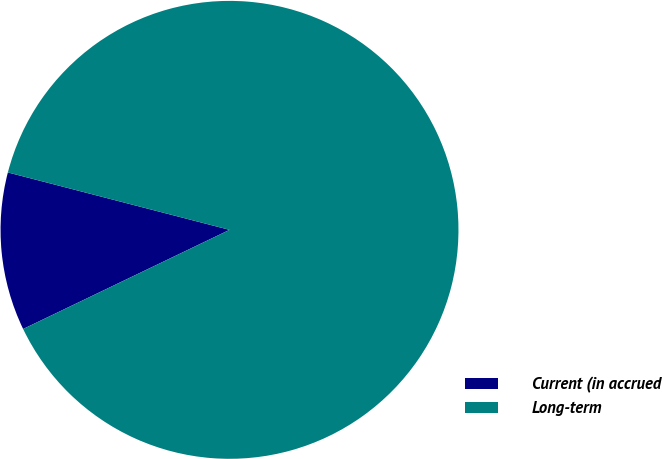Convert chart. <chart><loc_0><loc_0><loc_500><loc_500><pie_chart><fcel>Current (in accrued<fcel>Long-term<nl><fcel>11.16%<fcel>88.84%<nl></chart> 